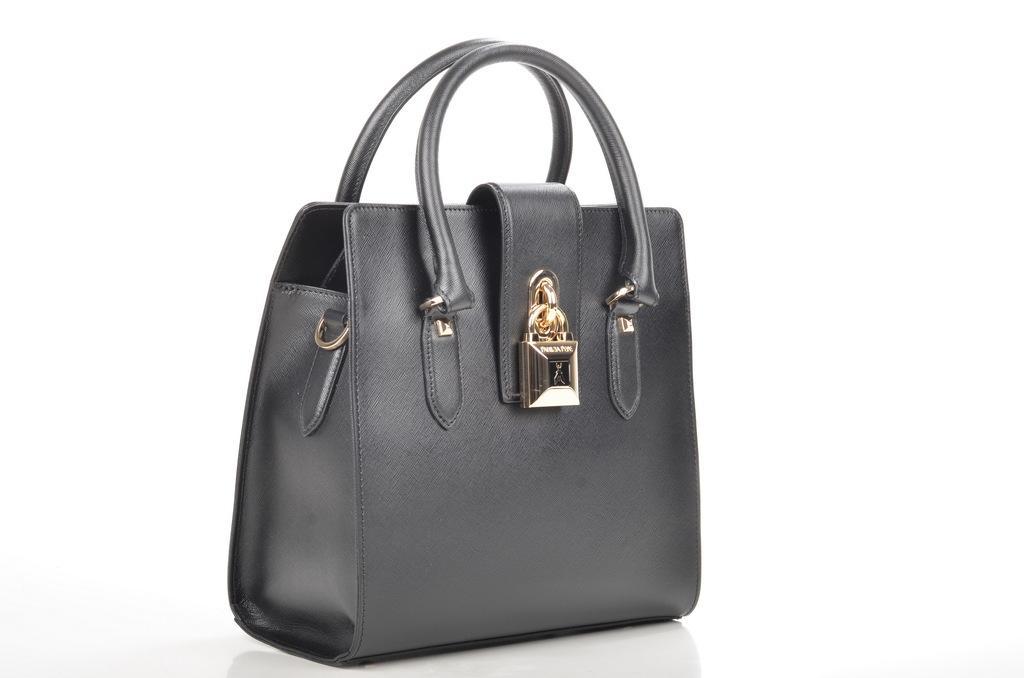Could you give a brief overview of what you see in this image? In this picture there is a handbag made of leather and has a holder which is painted as golden decorative object on it 